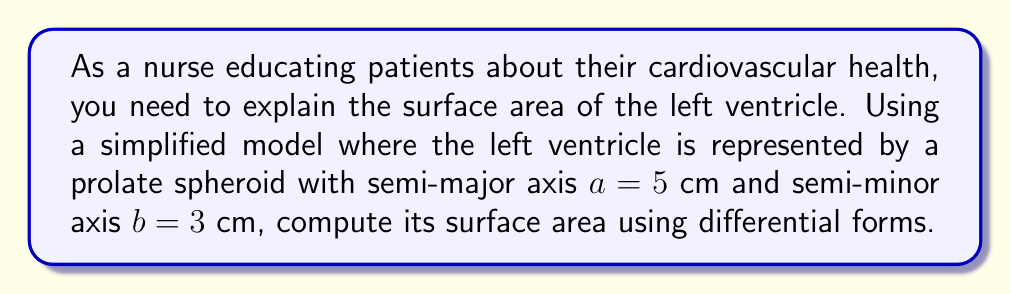What is the answer to this math problem? To compute the surface area of the left ventricle modeled as a prolate spheroid, we'll follow these steps:

1) The parametric equations for a prolate spheroid are:
   $$x = a \sin\theta \cos\phi$$
   $$y = a \sin\theta \sin\phi$$
   $$z = b \cos\theta$$
   where $0 \leq \theta \leq \pi$ and $0 \leq \phi \leq 2\pi$

2) We need to find the differential form $\omega$ that represents the surface area element. This is given by:
   $$\omega = \sqrt{EG - F^2} \, d\theta \wedge d\phi$$
   where $E, F, G$ are the coefficients of the first fundamental form.

3) Calculate the partial derivatives:
   $$\frac{\partial \mathbf{r}}{\partial \theta} = (a \cos\theta \cos\phi, a \cos\theta \sin\phi, -b \sin\theta)$$
   $$\frac{\partial \mathbf{r}}{\partial \phi} = (-a \sin\theta \sin\phi, a \sin\theta \cos\phi, 0)$$

4) Compute $E, F, G$:
   $$E = \left(\frac{\partial \mathbf{r}}{\partial \theta}\right)^2 = a^2 \cos^2\theta + b^2 \sin^2\theta$$
   $$F = \frac{\partial \mathbf{r}}{\partial \theta} \cdot \frac{\partial \mathbf{r}}{\partial \phi} = 0$$
   $$G = \left(\frac{\partial \mathbf{r}}{\partial \phi}\right)^2 = a^2 \sin^2\theta$$

5) The surface area element is:
   $$\omega = \sqrt{(a^2 \cos^2\theta + b^2 \sin^2\theta)(a^2 \sin^2\theta)} \, d\theta \wedge d\phi$$
   $$= a \sin\theta \sqrt{a^2 \cos^2\theta + b^2 \sin^2\theta} \, d\theta \wedge d\phi$$

6) The surface area is the integral of this form over the parameter space:
   $$A = \int_0^{2\pi} \int_0^{\pi} a \sin\theta \sqrt{a^2 \cos^2\theta + b^2 \sin^2\theta} \, d\theta \, d\phi$$

7) Evaluate the integral:
   $$A = 2\pi a \int_0^{\pi} \sin\theta \sqrt{a^2 \cos^2\theta + b^2 \sin^2\theta} \, d\theta$$

8) This integral doesn't have a simple closed form. We can use the approximation:
   $$A \approx 2\pi ab \left(1 + \frac{1-e^2}{2e} \ln\left(\frac{1+e}{1-e}\right)\right)$$
   where $e = \sqrt{1-\frac{b^2}{a^2}}$ is the eccentricity.

9) Calculate $e$:
   $$e = \sqrt{1-\frac{3^2}{5^2}} = \sqrt{1-\frac{9}{25}} = \frac{4}{5}$$

10) Substitute the values:
    $$A \approx 2\pi \cdot 5 \cdot 3 \left(1 + \frac{1-(\frac{4}{5})^2}{2\cdot\frac{4}{5}} \ln\left(\frac{1+\frac{4}{5}}{1-\frac{4}{5}}\right)\right)$$
    $$\approx 30\pi \left(1 + \frac{9}{40} \ln(9)\right) \approx 231.57 \text{ cm}^2$$
Answer: $231.57 \text{ cm}^2$ 